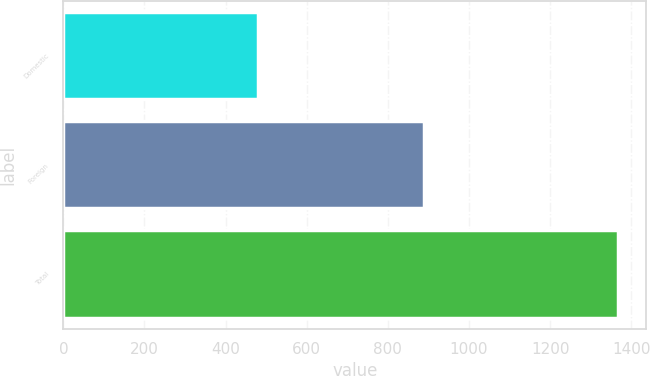Convert chart to OTSL. <chart><loc_0><loc_0><loc_500><loc_500><bar_chart><fcel>Domestic<fcel>Foreign<fcel>Total<nl><fcel>480<fcel>888<fcel>1368<nl></chart> 